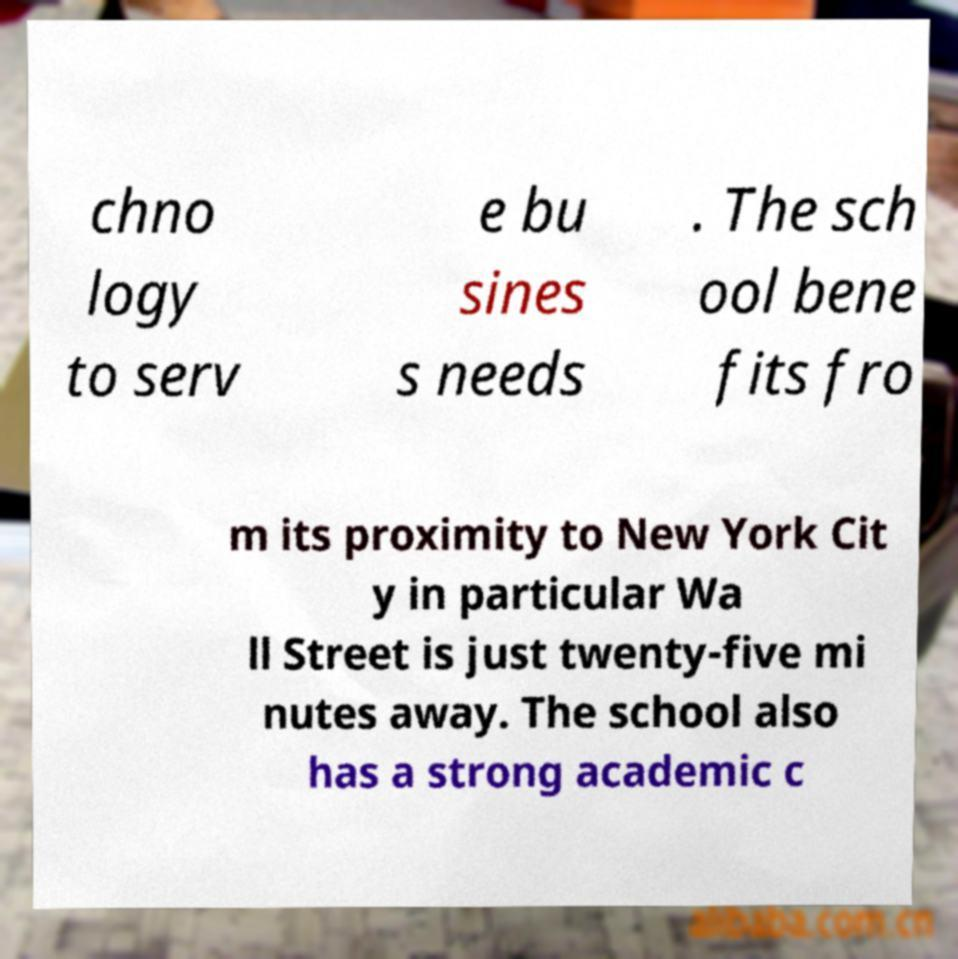I need the written content from this picture converted into text. Can you do that? chno logy to serv e bu sines s needs . The sch ool bene fits fro m its proximity to New York Cit y in particular Wa ll Street is just twenty-five mi nutes away. The school also has a strong academic c 